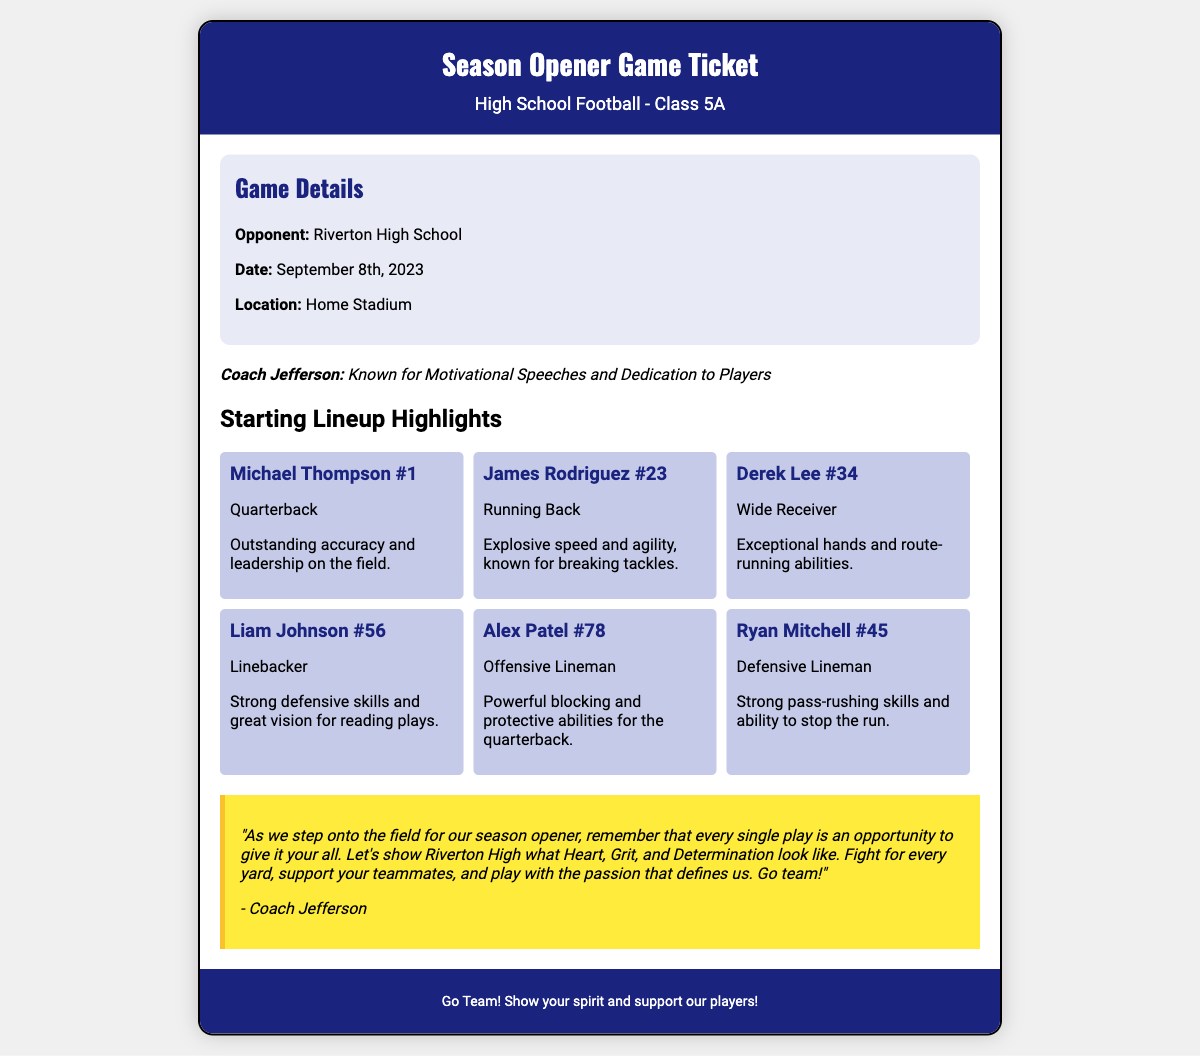What is the date of the game? The date of the game is specified in the document as September 8th, 2023.
Answer: September 8th, 2023 Who is the opponent team? The document clearly states that the opponent team is Riverton High School.
Answer: Riverton High School What is Michael Thompson's jersey number? The jersey number for Michael Thompson is mentioned in the document as #1.
Answer: #1 What position does James Rodriguez play? The document lists James Rodriguez as the Running Back.
Answer: Running Back Which player is noted for exceptional hands? Derek Lee is mentioned in the document as having exceptional hands and route-running abilities.
Answer: Derek Lee Who is responsible for strong blocking on the offensive line? Alex Patel is identified in the document as responsible for powerful blocking and protective abilities.
Answer: Alex Patel How many players are listed in the starting lineup? The document contains information about 6 players listed in the starting lineup.
Answer: 6 What is the motivational note's primary focus? The motivational note emphasizes fighting for every yard and supporting teammates on the field.
Answer: Heart, Grit, and Determination What is the role of Ryan Mitchell on the team? Ryan Mitchell's role is specified as Defensive Lineman in the document.
Answer: Defensive Lineman 